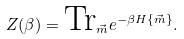<formula> <loc_0><loc_0><loc_500><loc_500>Z ( \beta ) = \text {Tr} _ { \vec { m } } e ^ { - \beta H \{ \vec { m } \} } .</formula> 